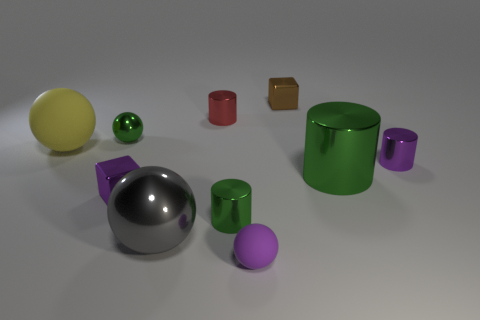Are there the same number of purple cubes behind the tiny brown metallic object and big cyan matte cylinders?
Give a very brief answer. Yes. How many large yellow things are made of the same material as the large gray thing?
Offer a very short reply. 0. The large cylinder that is made of the same material as the small green sphere is what color?
Make the answer very short. Green. Is the size of the green sphere the same as the rubber ball on the left side of the tiny metallic ball?
Ensure brevity in your answer.  No. The yellow thing has what shape?
Provide a succinct answer. Sphere. What number of tiny balls have the same color as the large metal cylinder?
Ensure brevity in your answer.  1. There is another large matte object that is the same shape as the large gray thing; what color is it?
Make the answer very short. Yellow. How many red cylinders are on the right side of the purple metallic object to the right of the small green cylinder?
Offer a very short reply. 0. What number of blocks are small brown shiny objects or tiny cyan rubber things?
Your response must be concise. 1. Are any big green metallic things visible?
Keep it short and to the point. Yes. 